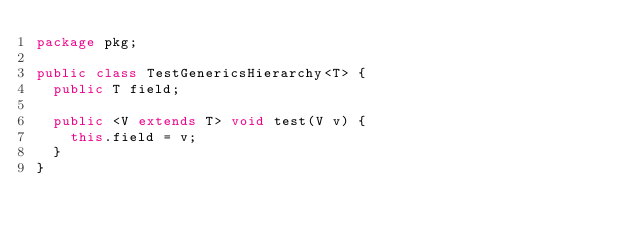Convert code to text. <code><loc_0><loc_0><loc_500><loc_500><_Java_>package pkg;

public class TestGenericsHierarchy<T> {
  public T field;

  public <V extends T> void test(V v) {
    this.field = v;
  }
}
</code> 